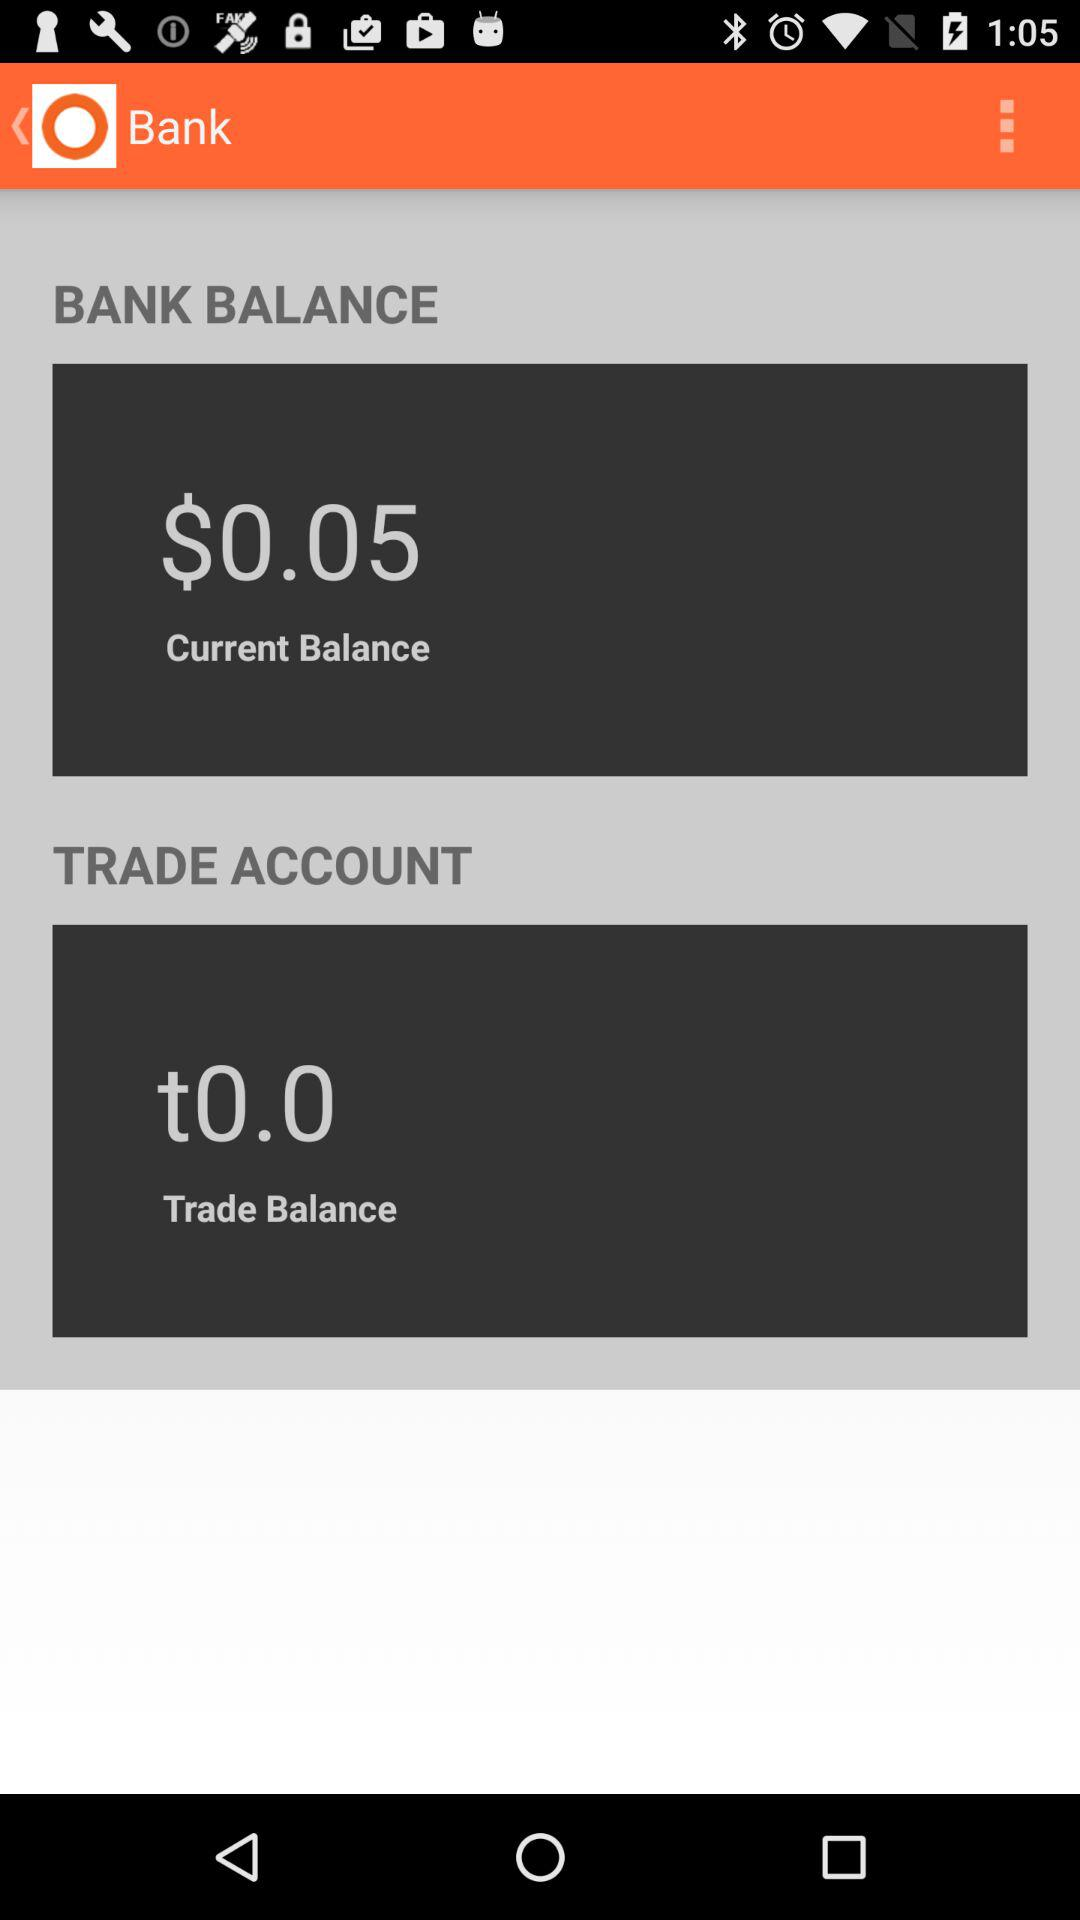How much was the balance yesterday?
When the provided information is insufficient, respond with <no answer>. <no answer> 